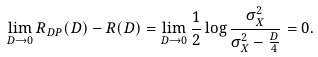Convert formula to latex. <formula><loc_0><loc_0><loc_500><loc_500>\lim _ { D \rightarrow 0 } R _ { D P } ( D ) - R ( D ) = \lim _ { D \rightarrow 0 } \frac { 1 } { 2 } \log \frac { \sigma _ { X } ^ { 2 } } { \sigma _ { X } ^ { 2 } - \frac { D } { 4 } } = 0 .</formula> 